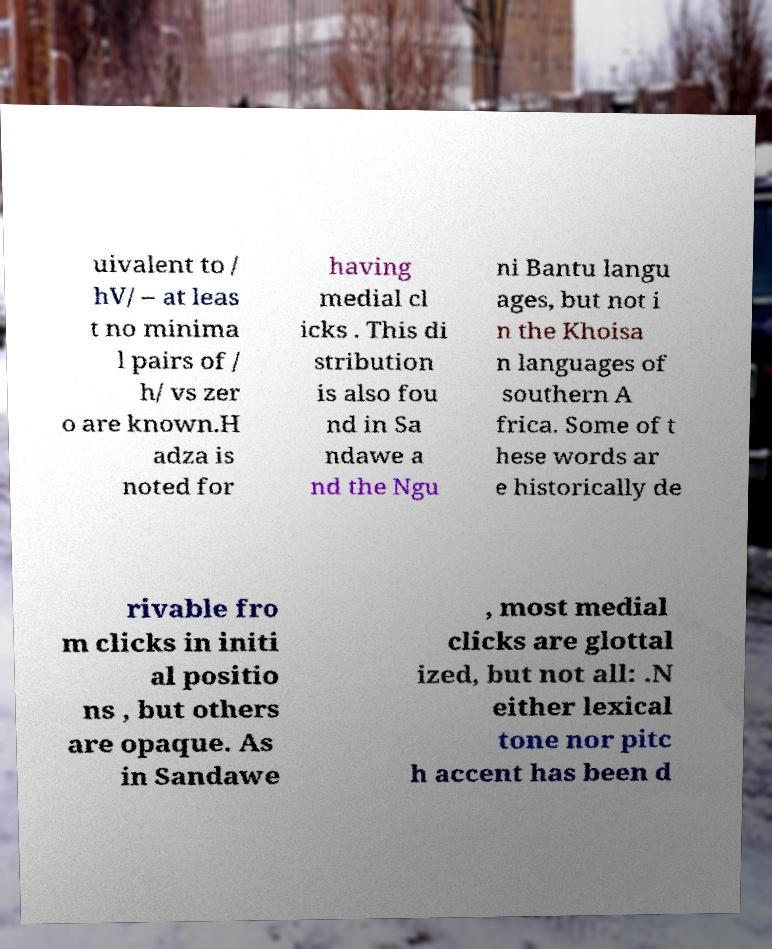Could you extract and type out the text from this image? uivalent to / hV/ – at leas t no minima l pairs of / h/ vs zer o are known.H adza is noted for having medial cl icks . This di stribution is also fou nd in Sa ndawe a nd the Ngu ni Bantu langu ages, but not i n the Khoisa n languages of southern A frica. Some of t hese words ar e historically de rivable fro m clicks in initi al positio ns , but others are opaque. As in Sandawe , most medial clicks are glottal ized, but not all: .N either lexical tone nor pitc h accent has been d 